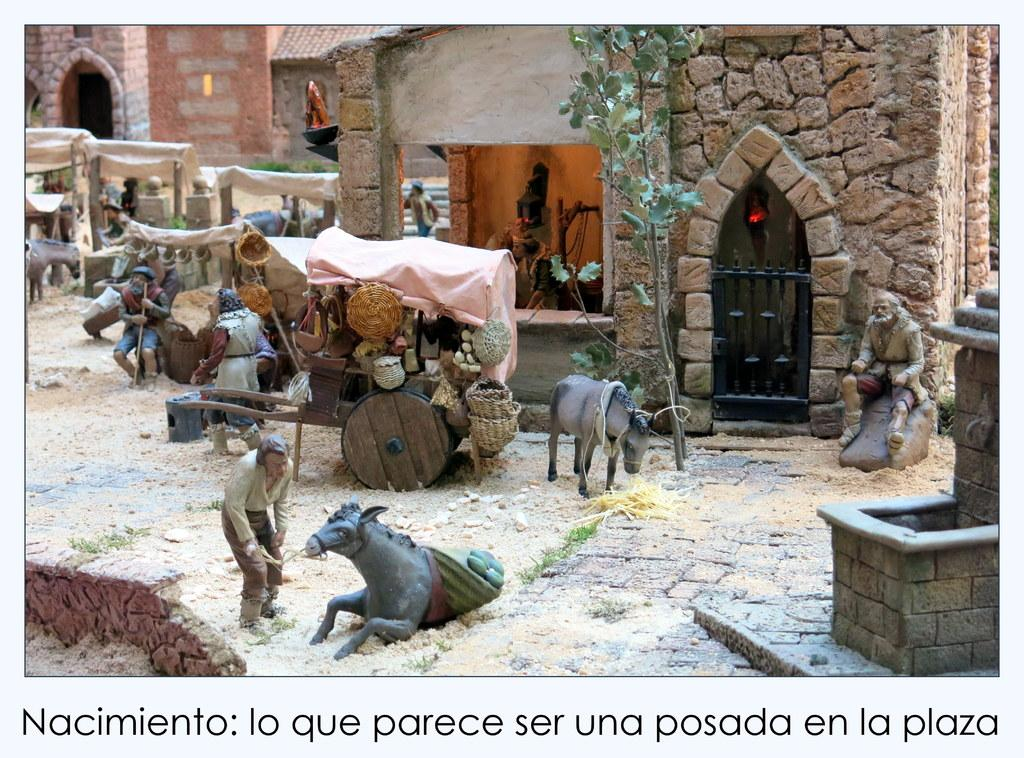What types of sculptures can be seen in the image? There are sculptures of persons and animals in the image. What else is present in the image besides the sculptures? There is a vehicle, a building, trees, tents, and text at the bottom of the image. Can you describe the vehicle in the image? The facts provided do not give specific details about the vehicle. What is the purpose of the tents in the image? The purpose of the tents is not clear from the provided facts, but they are visible in the middle of the image. What type of substance is being poured into the liquid in the image? There is no substance being poured into a liquid in the image; the facts provided do not mention any liquids. 